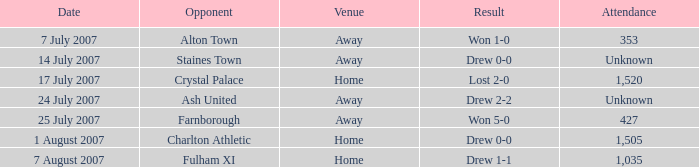Name the attendance with result of won 1-0 353.0. 